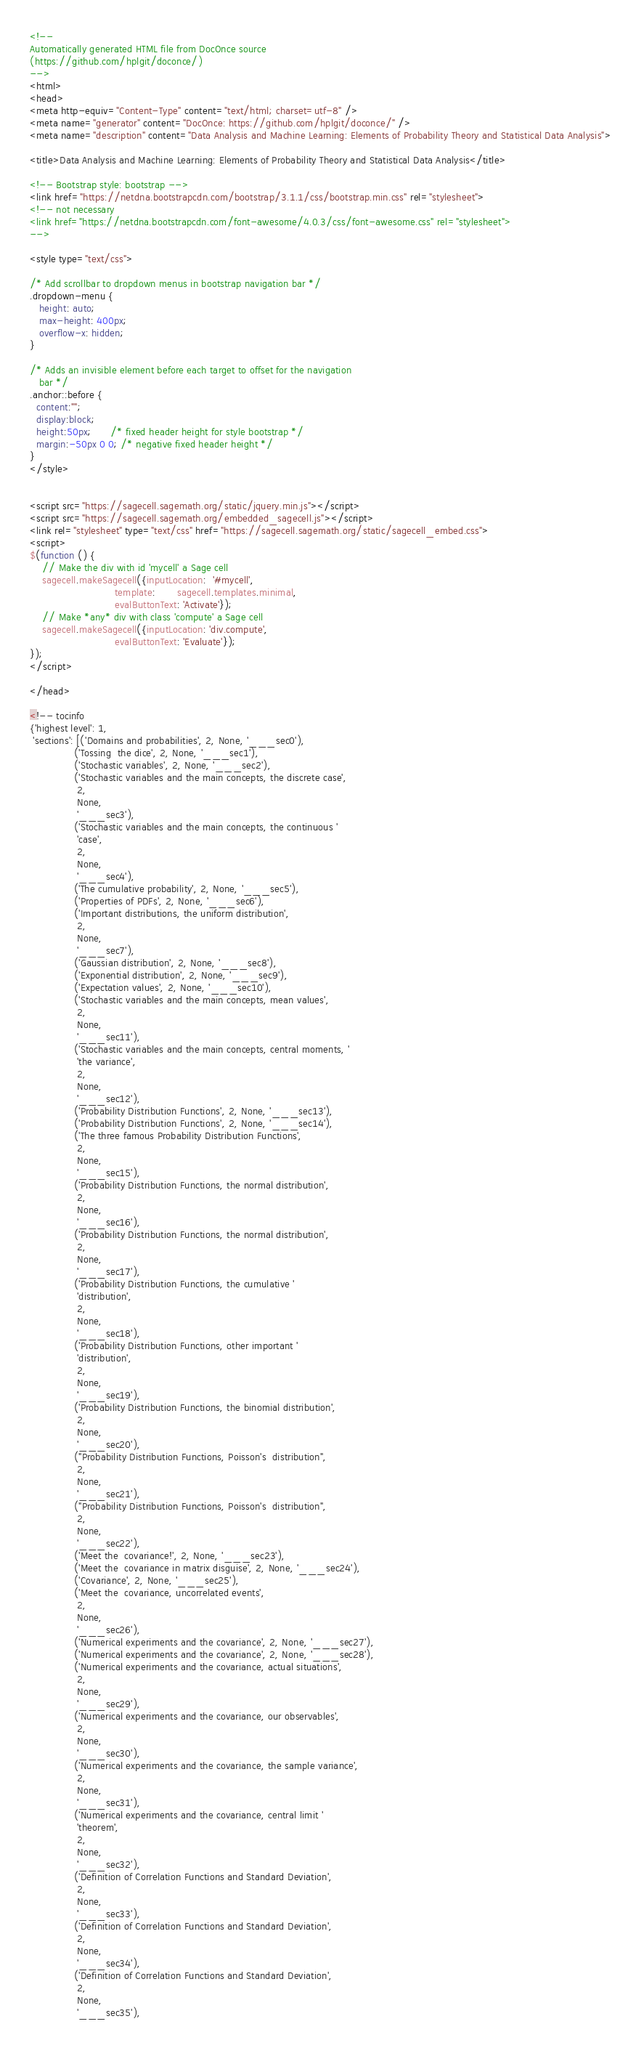<code> <loc_0><loc_0><loc_500><loc_500><_HTML_><!--
Automatically generated HTML file from DocOnce source
(https://github.com/hplgit/doconce/)
-->
<html>
<head>
<meta http-equiv="Content-Type" content="text/html; charset=utf-8" />
<meta name="generator" content="DocOnce: https://github.com/hplgit/doconce/" />
<meta name="description" content="Data Analysis and Machine Learning: Elements of Probability Theory and Statistical Data Analysis">

<title>Data Analysis and Machine Learning: Elements of Probability Theory and Statistical Data Analysis</title>

<!-- Bootstrap style: bootstrap -->
<link href="https://netdna.bootstrapcdn.com/bootstrap/3.1.1/css/bootstrap.min.css" rel="stylesheet">
<!-- not necessary
<link href="https://netdna.bootstrapcdn.com/font-awesome/4.0.3/css/font-awesome.css" rel="stylesheet">
-->

<style type="text/css">

/* Add scrollbar to dropdown menus in bootstrap navigation bar */
.dropdown-menu {
   height: auto;
   max-height: 400px;
   overflow-x: hidden;
}

/* Adds an invisible element before each target to offset for the navigation
   bar */
.anchor::before {
  content:"";
  display:block;
  height:50px;      /* fixed header height for style bootstrap */
  margin:-50px 0 0; /* negative fixed header height */
}
</style>


<script src="https://sagecell.sagemath.org/static/jquery.min.js"></script>
<script src="https://sagecell.sagemath.org/embedded_sagecell.js"></script>
<link rel="stylesheet" type="text/css" href="https://sagecell.sagemath.org/static/sagecell_embed.css">
<script>
$(function () {
    // Make the div with id 'mycell' a Sage cell
    sagecell.makeSagecell({inputLocation:  '#mycell',
                           template:       sagecell.templates.minimal,
                           evalButtonText: 'Activate'});
    // Make *any* div with class 'compute' a Sage cell
    sagecell.makeSagecell({inputLocation: 'div.compute',
                           evalButtonText: 'Evaluate'});
});
</script>

</head>

<!-- tocinfo
{'highest level': 1,
 'sections': [('Domains and probabilities', 2, None, '___sec0'),
              ('Tossing  the dice', 2, None, '___sec1'),
              ('Stochastic variables', 2, None, '___sec2'),
              ('Stochastic variables and the main concepts, the discrete case',
               2,
               None,
               '___sec3'),
              ('Stochastic variables and the main concepts, the continuous '
               'case',
               2,
               None,
               '___sec4'),
              ('The cumulative probability', 2, None, '___sec5'),
              ('Properties of PDFs', 2, None, '___sec6'),
              ('Important distributions, the uniform distribution',
               2,
               None,
               '___sec7'),
              ('Gaussian distribution', 2, None, '___sec8'),
              ('Exponential distribution', 2, None, '___sec9'),
              ('Expectation values', 2, None, '___sec10'),
              ('Stochastic variables and the main concepts, mean values',
               2,
               None,
               '___sec11'),
              ('Stochastic variables and the main concepts, central moments, '
               'the variance',
               2,
               None,
               '___sec12'),
              ('Probability Distribution Functions', 2, None, '___sec13'),
              ('Probability Distribution Functions', 2, None, '___sec14'),
              ('The three famous Probability Distribution Functions',
               2,
               None,
               '___sec15'),
              ('Probability Distribution Functions, the normal distribution',
               2,
               None,
               '___sec16'),
              ('Probability Distribution Functions, the normal distribution',
               2,
               None,
               '___sec17'),
              ('Probability Distribution Functions, the cumulative '
               'distribution',
               2,
               None,
               '___sec18'),
              ('Probability Distribution Functions, other important '
               'distribution',
               2,
               None,
               '___sec19'),
              ('Probability Distribution Functions, the binomial distribution',
               2,
               None,
               '___sec20'),
              ("Probability Distribution Functions, Poisson's  distribution",
               2,
               None,
               '___sec21'),
              ("Probability Distribution Functions, Poisson's  distribution",
               2,
               None,
               '___sec22'),
              ('Meet the  covariance!', 2, None, '___sec23'),
              ('Meet the  covariance in matrix disguise', 2, None, '___sec24'),
              ('Covariance', 2, None, '___sec25'),
              ('Meet the  covariance, uncorrelated events',
               2,
               None,
               '___sec26'),
              ('Numerical experiments and the covariance', 2, None, '___sec27'),
              ('Numerical experiments and the covariance', 2, None, '___sec28'),
              ('Numerical experiments and the covariance, actual situations',
               2,
               None,
               '___sec29'),
              ('Numerical experiments and the covariance, our observables',
               2,
               None,
               '___sec30'),
              ('Numerical experiments and the covariance, the sample variance',
               2,
               None,
               '___sec31'),
              ('Numerical experiments and the covariance, central limit '
               'theorem',
               2,
               None,
               '___sec32'),
              ('Definition of Correlation Functions and Standard Deviation',
               2,
               None,
               '___sec33'),
              ('Definition of Correlation Functions and Standard Deviation',
               2,
               None,
               '___sec34'),
              ('Definition of Correlation Functions and Standard Deviation',
               2,
               None,
               '___sec35'),</code> 